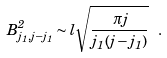<formula> <loc_0><loc_0><loc_500><loc_500>B _ { j _ { 1 } , j - j _ { 1 } } ^ { 2 } \sim l \sqrt { \frac { \pi j } { j _ { 1 } ( j - j _ { 1 } ) } } \ .</formula> 